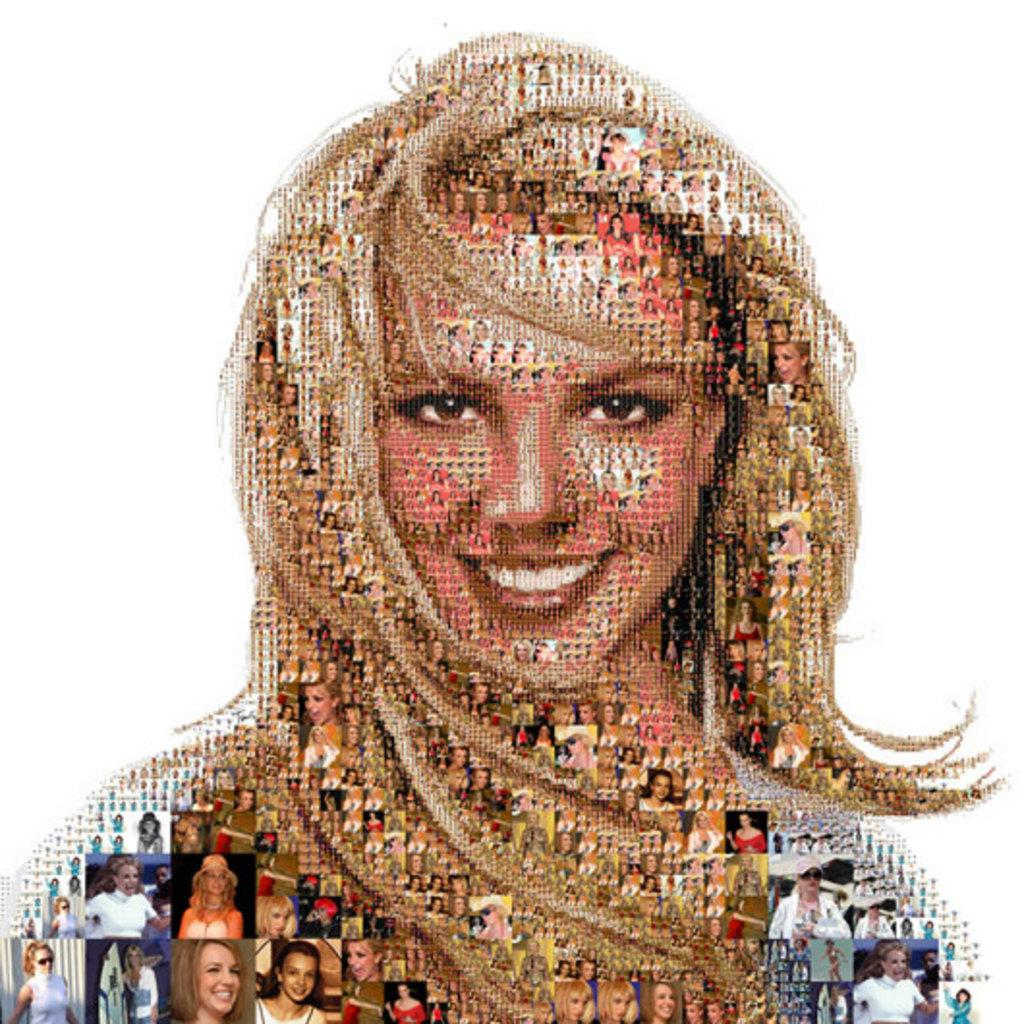What can be said about the nature of the image? The image is edited. Who or what is the main subject of the image? There is a depiction of a woman in the image. What color is the background of the image? The background of the image is white. What type of paste is the woman using in the image? There is no paste present in the image, as it features a depiction of a woman with a white background. 